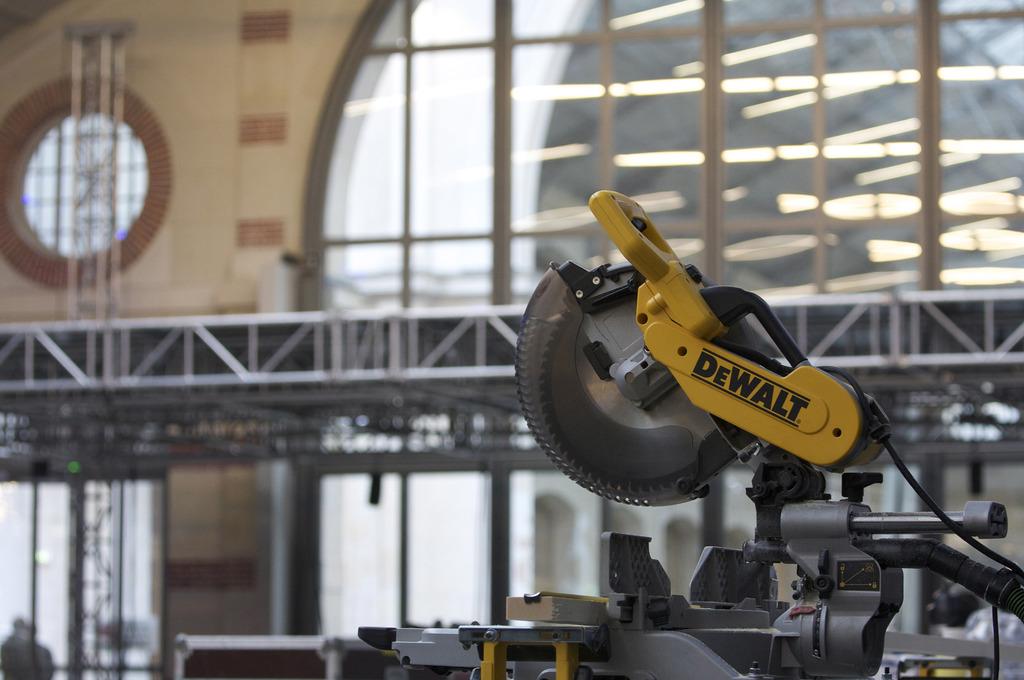What brand is this?
Give a very brief answer. Dewalt. Is this logo in lower case or capitalization?
Offer a very short reply. Capitalization. 